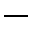Convert formula to latex. <formula><loc_0><loc_0><loc_500><loc_500>\_</formula> 